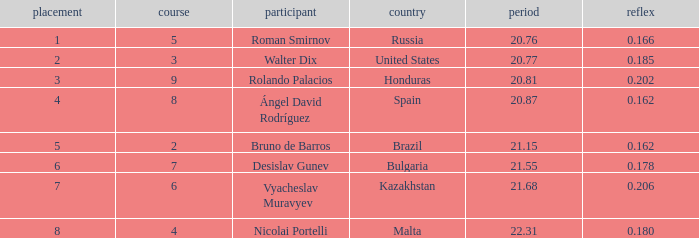What's Bulgaria's lane with a time more than 21.55? None. Parse the table in full. {'header': ['placement', 'course', 'participant', 'country', 'period', 'reflex'], 'rows': [['1', '5', 'Roman Smirnov', 'Russia', '20.76', '0.166'], ['2', '3', 'Walter Dix', 'United States', '20.77', '0.185'], ['3', '9', 'Rolando Palacios', 'Honduras', '20.81', '0.202'], ['4', '8', 'Ángel David Rodríguez', 'Spain', '20.87', '0.162'], ['5', '2', 'Bruno de Barros', 'Brazil', '21.15', '0.162'], ['6', '7', 'Desislav Gunev', 'Bulgaria', '21.55', '0.178'], ['7', '6', 'Vyacheslav Muravyev', 'Kazakhstan', '21.68', '0.206'], ['8', '4', 'Nicolai Portelli', 'Malta', '22.31', '0.180']]} 